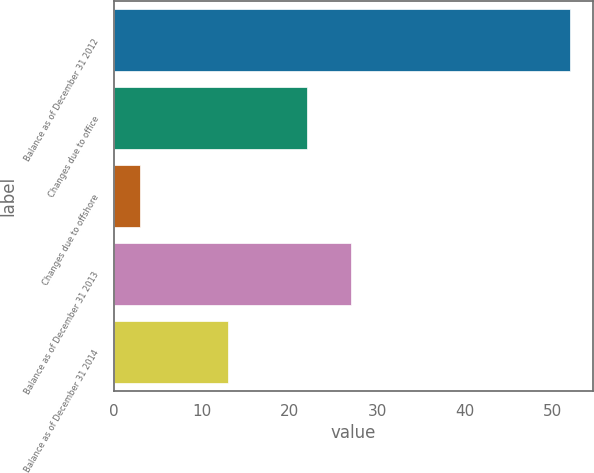Convert chart. <chart><loc_0><loc_0><loc_500><loc_500><bar_chart><fcel>Balance as of December 31 2012<fcel>Changes due to office<fcel>Changes due to offshore<fcel>Balance as of December 31 2013<fcel>Balance as of December 31 2014<nl><fcel>52<fcel>22<fcel>3<fcel>27<fcel>13<nl></chart> 